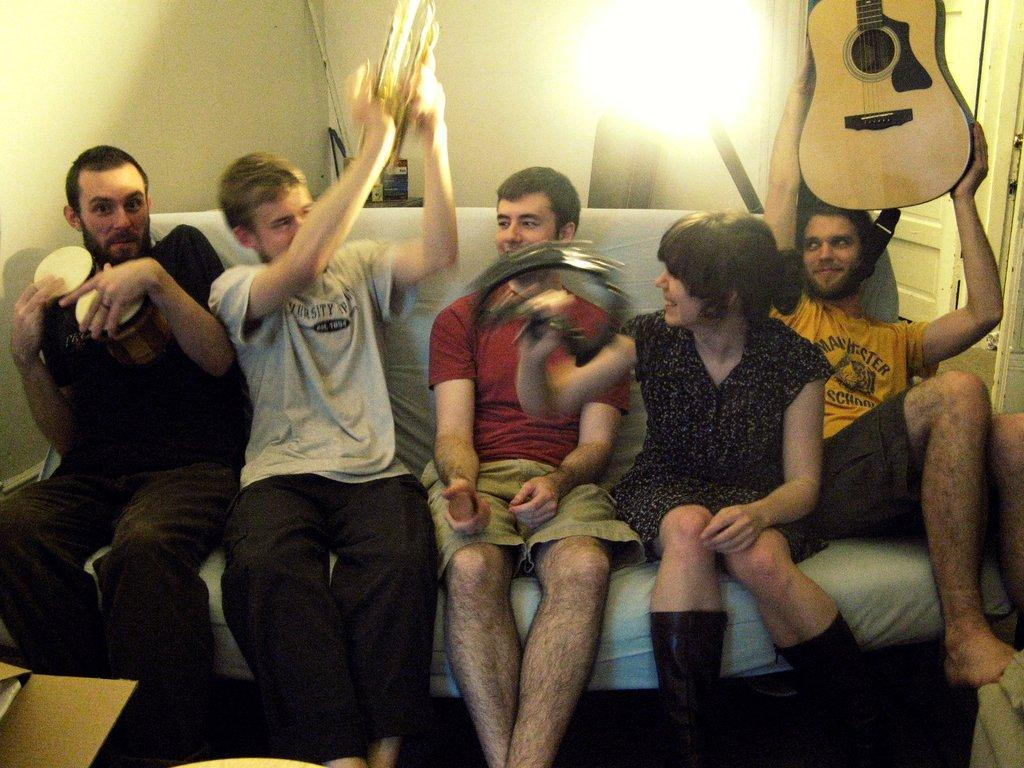How many people are in the image are sitting on a couch? There is a group of people in the image, and they are sitting on a couch. What is one person on the right side holding? One person on the right side is holding a guitar. What type of spring can be seen in the image? There is no spring present in the image. Is there a bottle or can visible in the image? The provided facts do not mention any bottles or cans in the image. 